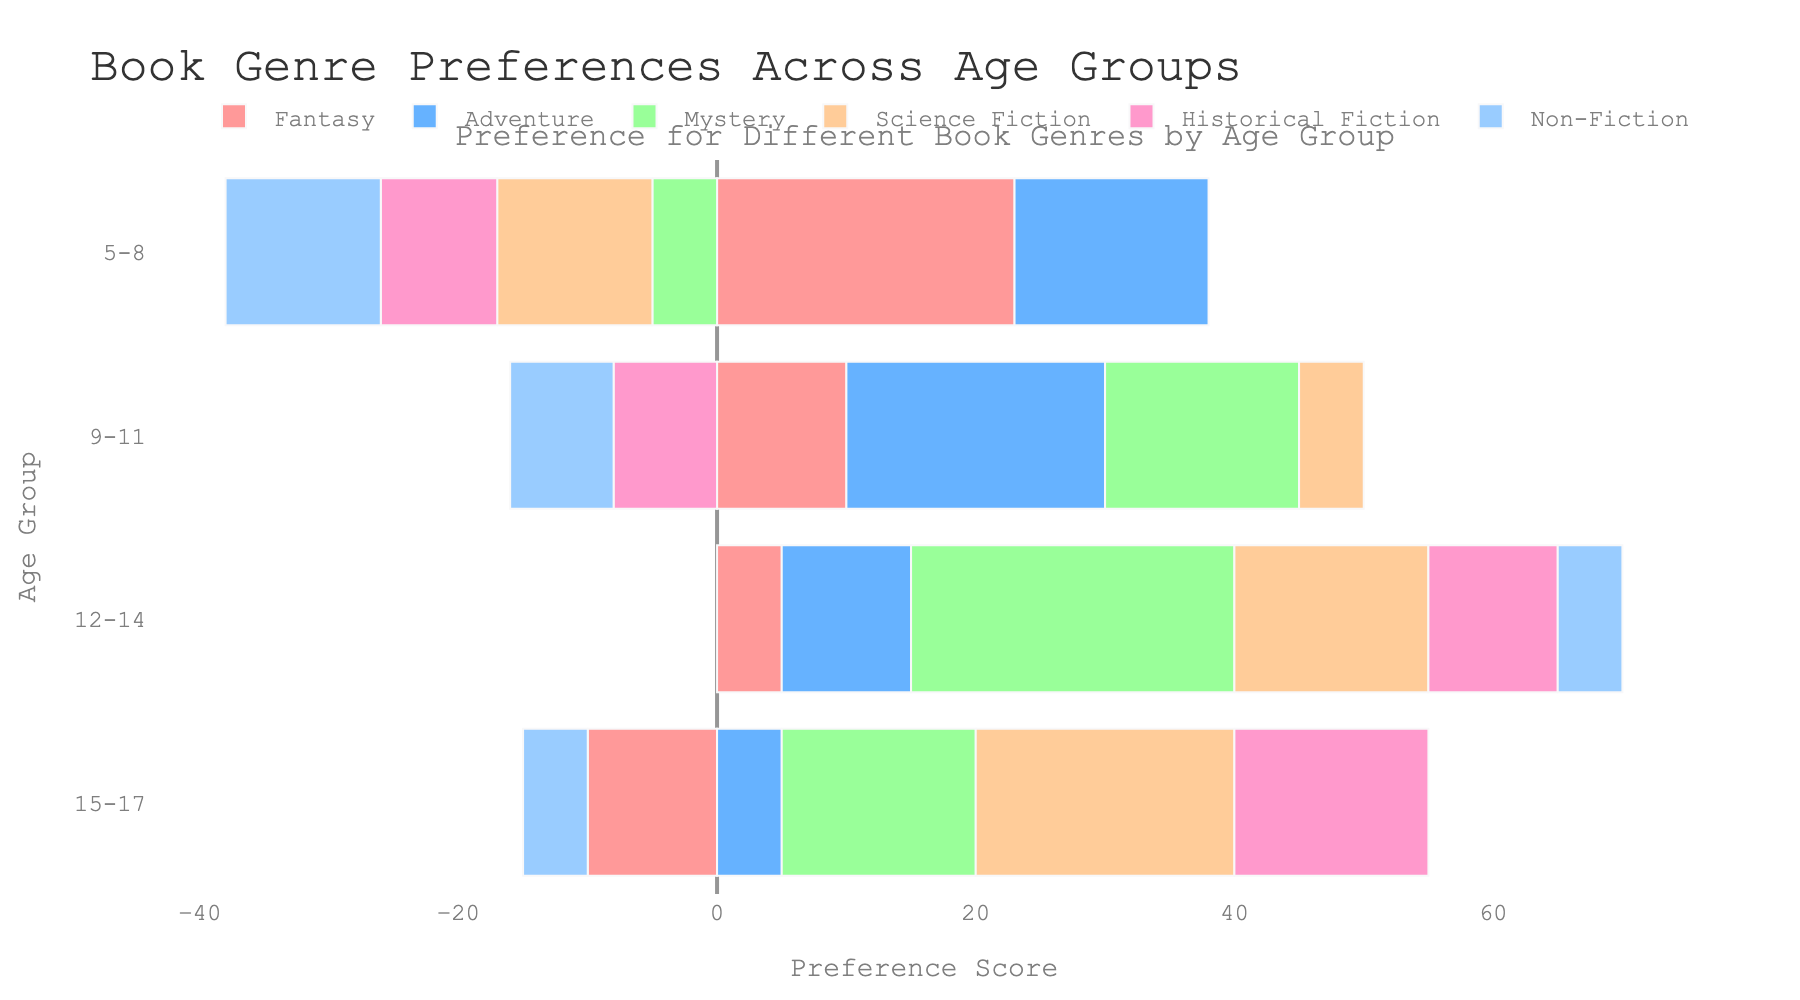Which age group prefers Fantasy the most? By inspecting the bar for the "Fantasy" genre, the age group with the highest positive value for Fantasy is 5-8 with a value of 23.
Answer: 5-8 Which genre has the least preference for the 15-17 age group? By looking at all the bars for the 15-17 age group, the genre with the most negative value is Fantasy with a value of -10.
Answer: Fantasy What is the total preference score for Adventure across all age groups? Summing the values for Adventure (15+20+10+5) = 50.
Answer: 50 Compare the preference for Mystery between the 5-8 and 12-14 age groups. The preference for Mystery in the age group 5-8 is -5 and for the age group 12-14 is 25. Comparing these values, 25 is much higher than -5.
Answer: 12-14 Which genre do the 9-11 age group prefer almost equally compared to Non-Fiction? For the 9-11 age group, Non-Fiction has a score of -8. Looking for a genre in the same age group that has a similar score, Historical Fiction also has a score of -8.
Answer: Historical Fiction What is the average preference score for Science Fiction across the age groups 9-11 and 15-17? For Science Fiction, the scores are 5 for 9-11 and 20 for 15-17. The average is calculated as (5 + 20) / 2 = 12.5
Answer: 12.5 Which age group shows a negative preference for most genres? Looking across all categories for each age group, the 5-8 age group has negative values for Mystery, Science Fiction, Historical Fiction, and Non-Fiction (total 4 genres).
Answer: 5-8 How does the preference for Historical Fiction change as age increases from 5-8 to 15-17? The preferences for Historical Fiction are -9, -8, 10, and 15 for age groups 5-8, 9-11, 12-14, and 15-17 respectively. The preference increases with age.
Answer: Increases Which genre has a positive preference across all age groups? Checking each genre across all age groups, only Adventure has positive values across all age groups.
Answer: Adventure 